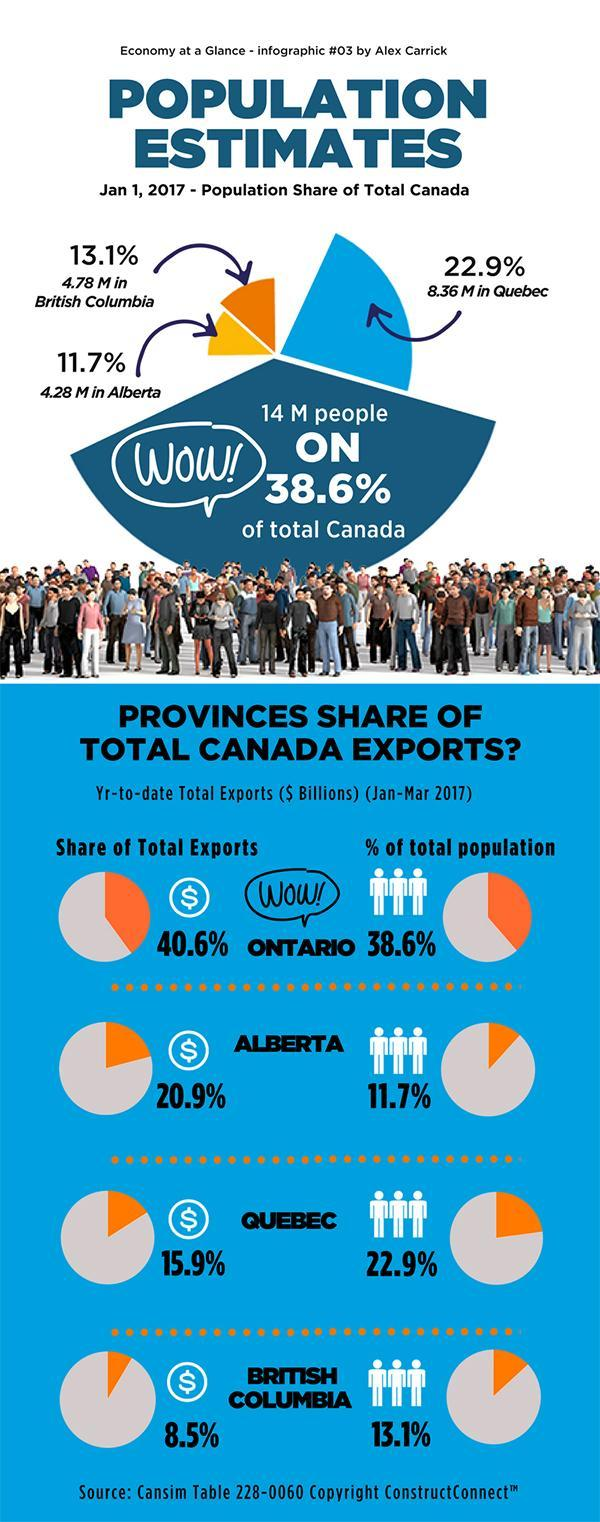What is the share of Quebec and British Columbia in total exports, taken together?
Answer the question with a short phrase. 24.4% What is the share of Ontario and Alberta in total exports, taken together? 61.5% What is the population of British Columbia and Quebec, taken together? 13.14 M What is the percentage of the population in Quebec and British Columbia, taken together? 36% What is the percentage of the population in Ontario and Alberta, taken together? 50.3% 